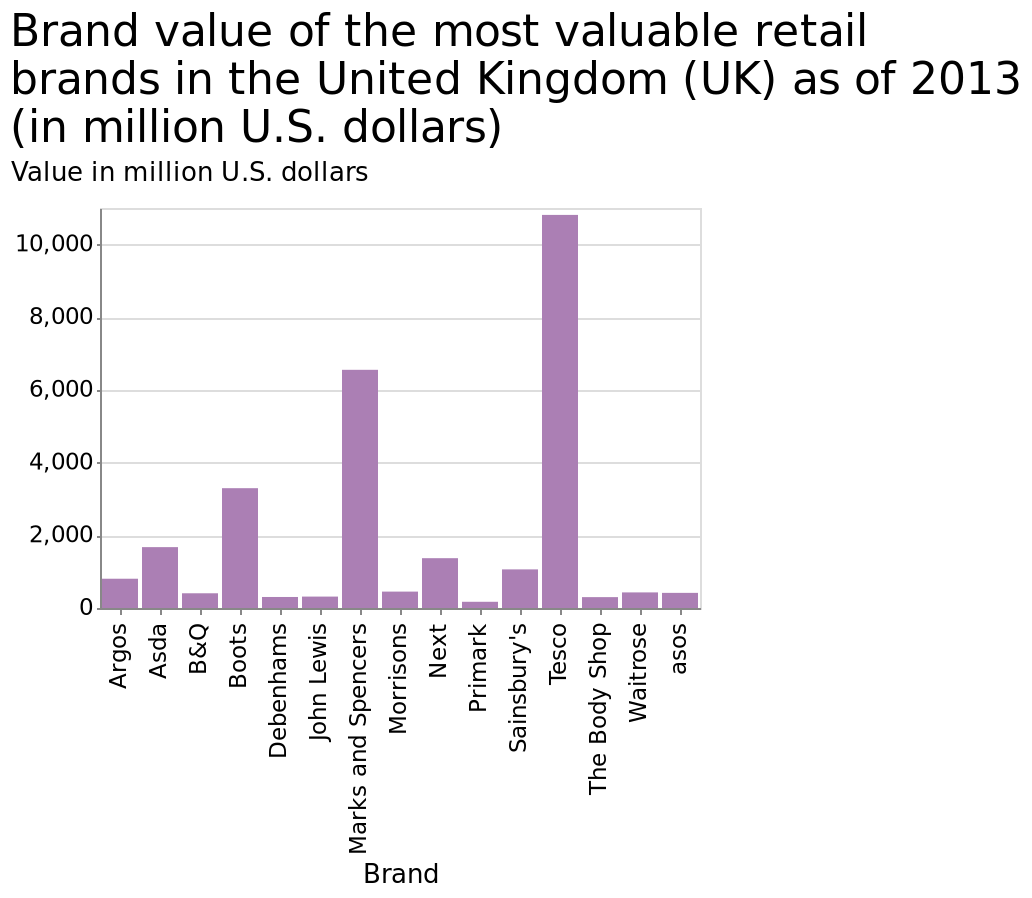<image>
please describe the details of the chart This bar diagram is labeled Brand value of the most valuable retail brands in the United Kingdom (UK) as of 2013 (in million U.S. dollars). The y-axis measures Value in million U.S. dollars while the x-axis measures Brand. What year does the bar diagram represent the Brand value for? The bar diagram represents the Brand value as of 2013. How does Tesco's annual value compare to other brands on the bar chart? Tesco's annual value exceeds that of any other brand on the bar chart. please summary the statistics and relations of the chart Tesco far exceeds their annual value than any other brand on the bar chart. 